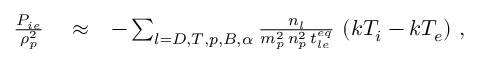Convert formula to latex. <formula><loc_0><loc_0><loc_500><loc_500>\begin{array} { r l r } { \frac { P _ { i e } } { \rho _ { p } ^ { 2 } } } & \approx } & { - \sum _ { l = D , T , p , B , \alpha } \frac { n _ { l } } { m _ { p } ^ { 2 } \, n _ { p } ^ { 2 } \, t _ { l e } ^ { e q } } \, \left ( k T _ { i } - k T _ { e } \right ) \, , } \end{array}</formula> 